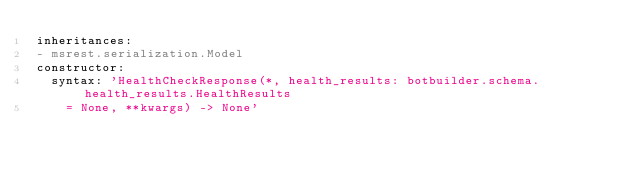Convert code to text. <code><loc_0><loc_0><loc_500><loc_500><_YAML_>inheritances:
- msrest.serialization.Model
constructor:
  syntax: 'HealthCheckResponse(*, health_results: botbuilder.schema.health_results.HealthResults
    = None, **kwargs) -> None'
</code> 